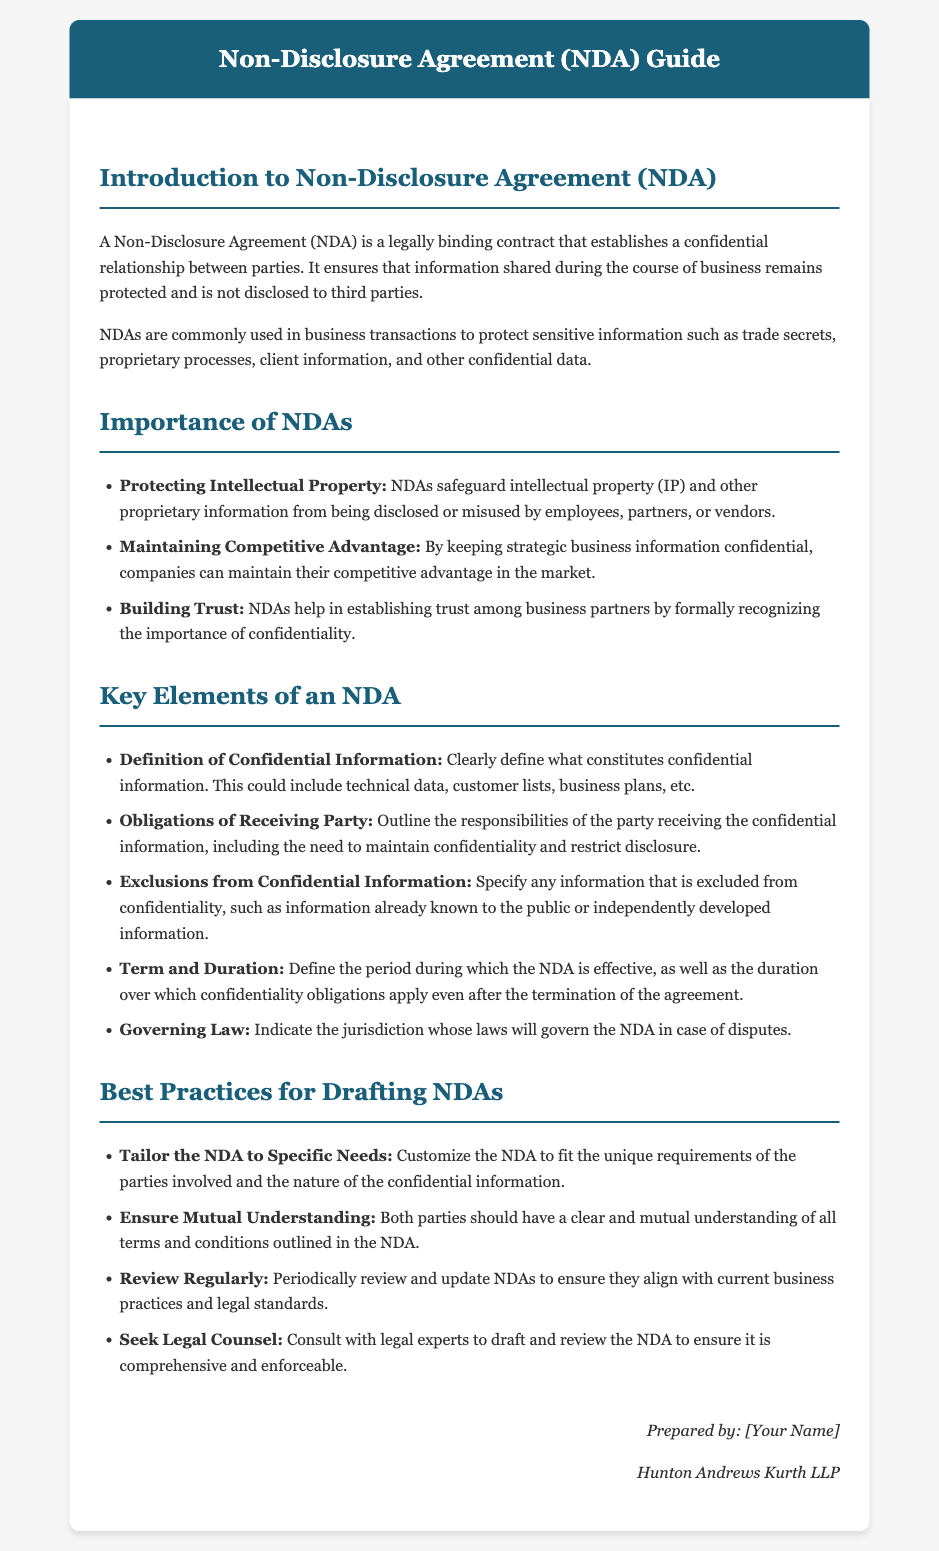What is a Non-Disclosure Agreement (NDA)? The document defines an NDA as a legally binding contract that establishes a confidential relationship between parties.
Answer: legally binding contract What is one reason why NDAs are important? The document lists several key reasons for the importance of NDAs, including protecting intellectual property.
Answer: protecting intellectual property What is one key element that should be clearly defined in an NDA? The document states that one key element is the definition of confidential information.
Answer: definition of confidential information How long should the NDA be effective? The document mentions the need to define the period during which the NDA is effective.
Answer: period during which the NDA is effective What is a best practice for drafting NDAs? One of the best practices mentioned is to tailor the NDA to specific needs.
Answer: tailor the NDA to specific needs What should both parties have according to best practices? The document emphasizes the importance of mutual understanding of all terms and conditions outlined in the NDA.
Answer: mutual understanding Which parties might benefit from an NDA? The document suggests that businesses, partners, and vendors benefit from NDAs to protect their interests.
Answer: businesses, partners, and vendors What is the purpose of the Exclusions from Confidential Information clause? The clause specifies any information excluded from confidentiality, such as information already known to the public.
Answer: information already known to the public What should companies do periodically with NDAs? The document suggests that companies should review and update NDAs to ensure they align with current practices.
Answer: review and update NDAs 